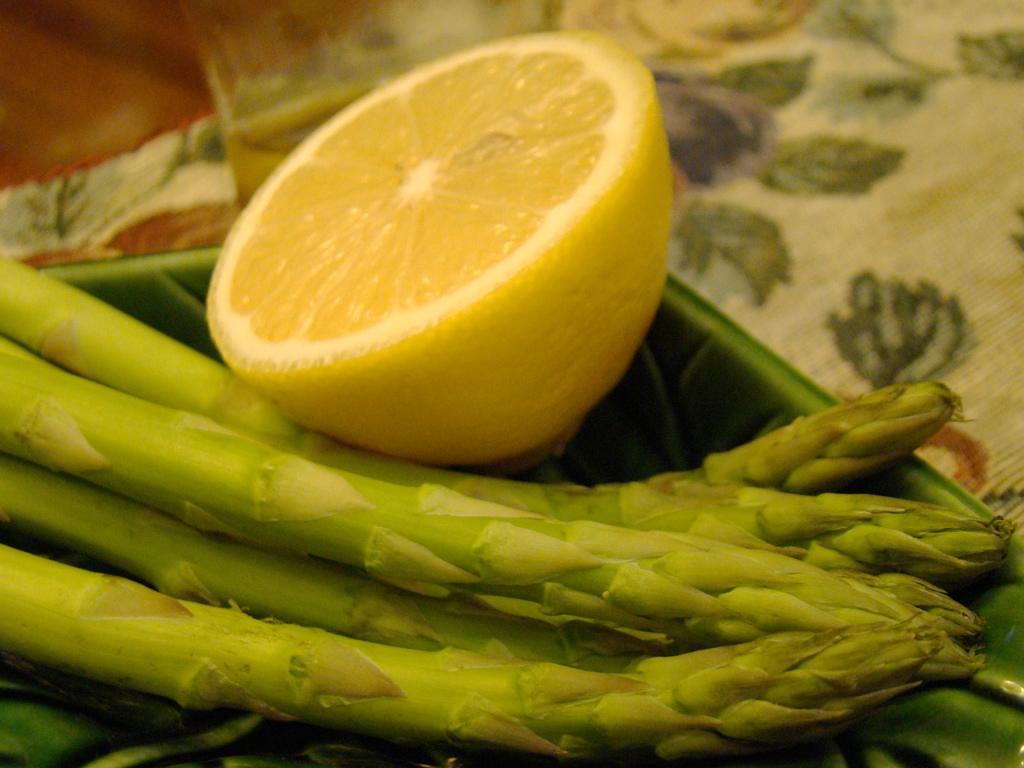Can you describe this image briefly? In this image there is a table and we can see a tray, asparagus and a lemon slice placed on the table. 